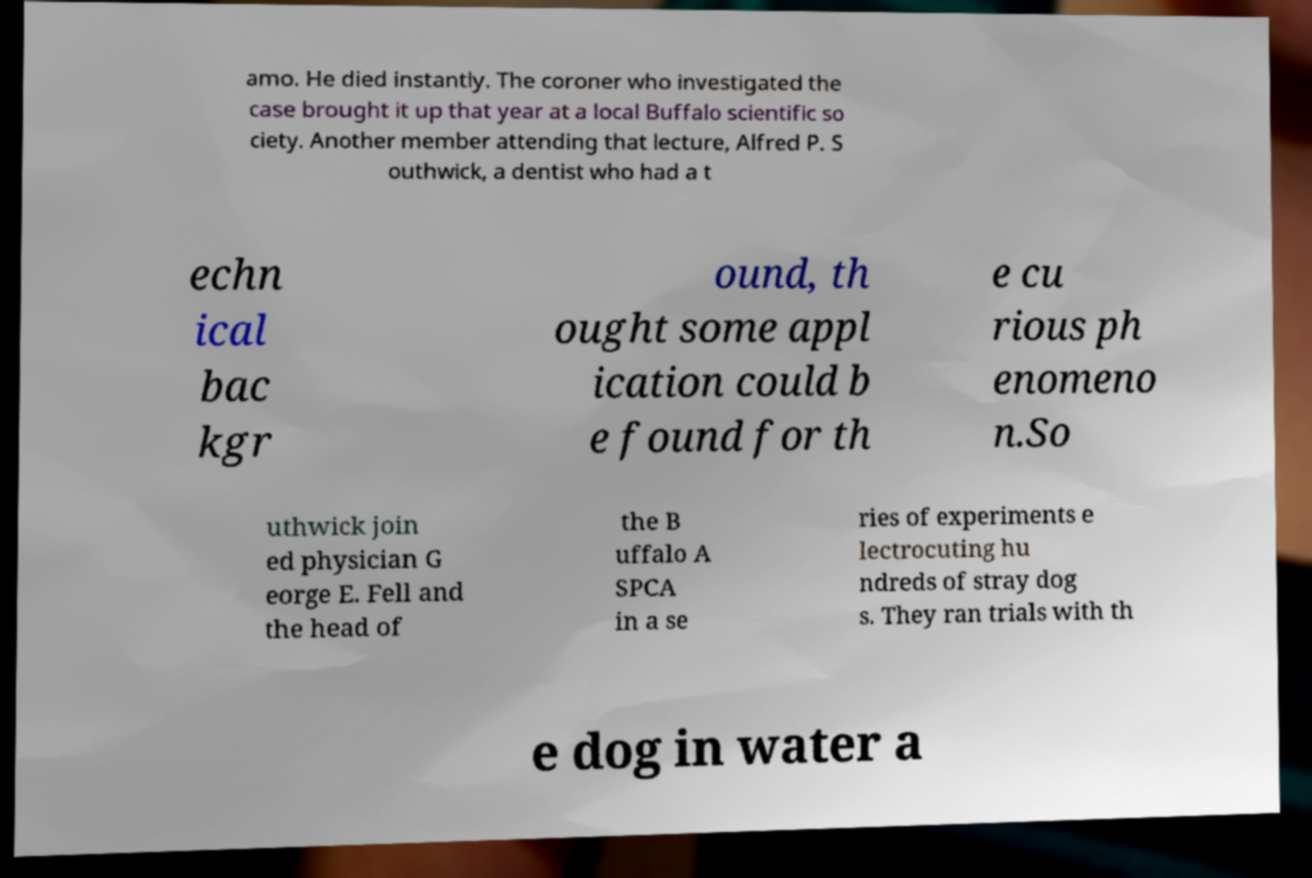I need the written content from this picture converted into text. Can you do that? amo. He died instantly. The coroner who investigated the case brought it up that year at a local Buffalo scientific so ciety. Another member attending that lecture, Alfred P. S outhwick, a dentist who had a t echn ical bac kgr ound, th ought some appl ication could b e found for th e cu rious ph enomeno n.So uthwick join ed physician G eorge E. Fell and the head of the B uffalo A SPCA in a se ries of experiments e lectrocuting hu ndreds of stray dog s. They ran trials with th e dog in water a 